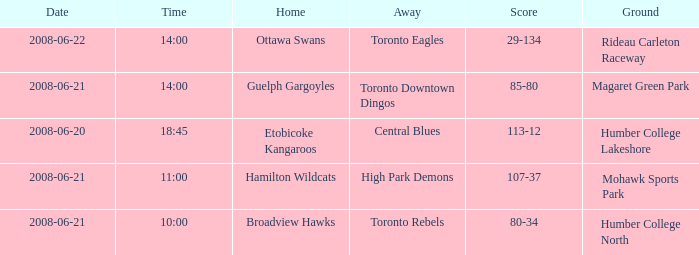What is the time for a score totaling 80-34? 10:00. Would you mind parsing the complete table? {'header': ['Date', 'Time', 'Home', 'Away', 'Score', 'Ground'], 'rows': [['2008-06-22', '14:00', 'Ottawa Swans', 'Toronto Eagles', '29-134', 'Rideau Carleton Raceway'], ['2008-06-21', '14:00', 'Guelph Gargoyles', 'Toronto Downtown Dingos', '85-80', 'Magaret Green Park'], ['2008-06-20', '18:45', 'Etobicoke Kangaroos', 'Central Blues', '113-12', 'Humber College Lakeshore'], ['2008-06-21', '11:00', 'Hamilton Wildcats', 'High Park Demons', '107-37', 'Mohawk Sports Park'], ['2008-06-21', '10:00', 'Broadview Hawks', 'Toronto Rebels', '80-34', 'Humber College North']]} 